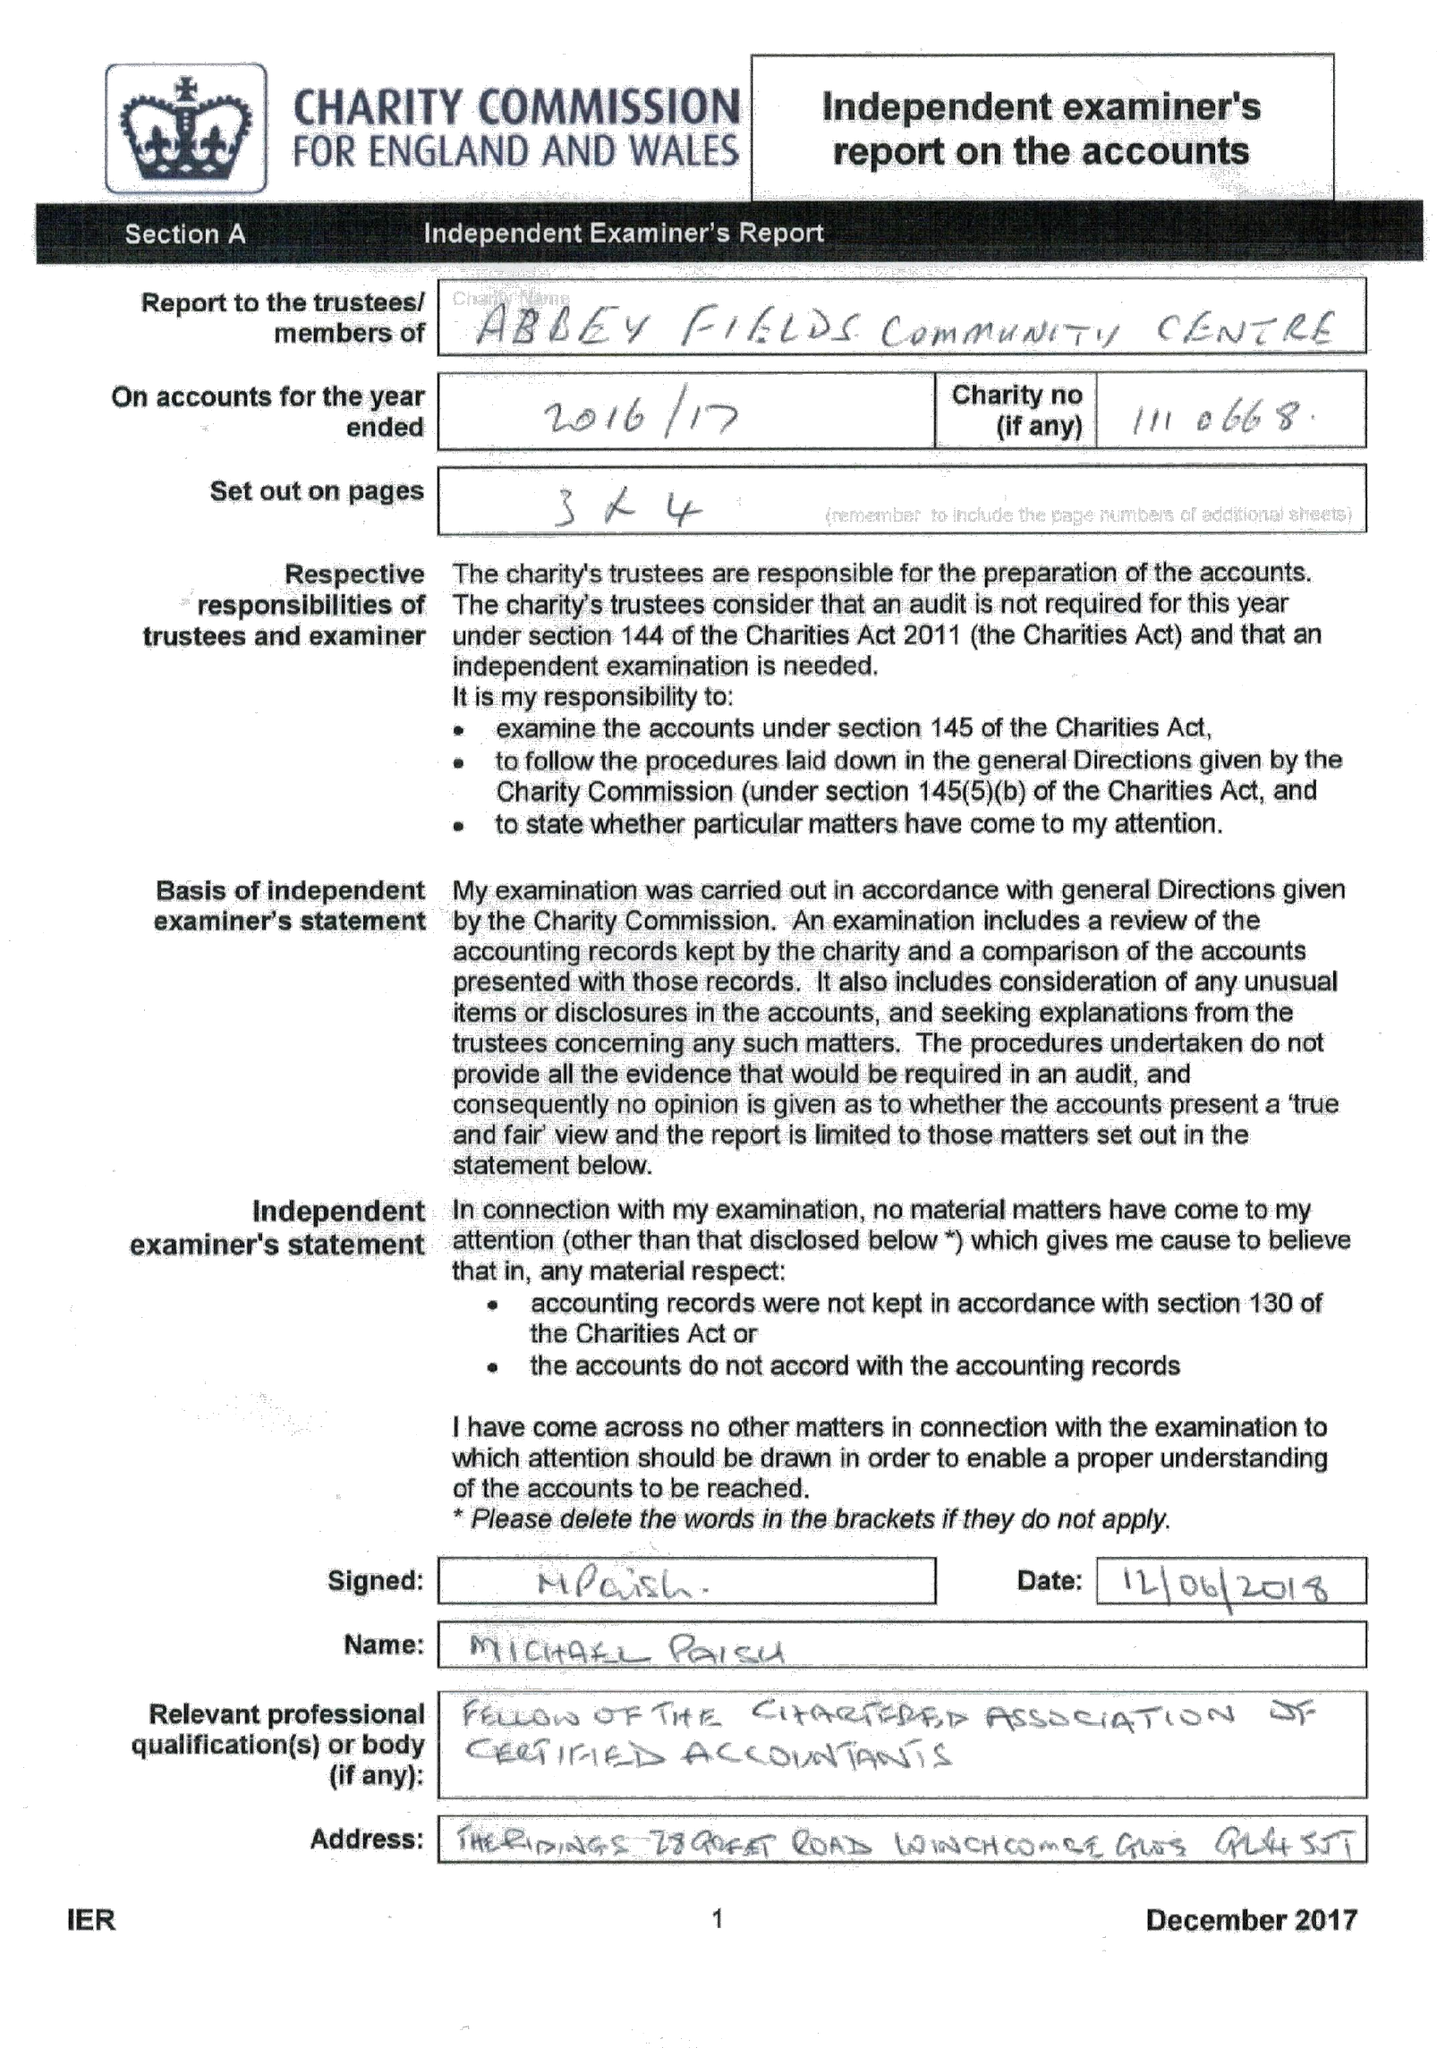What is the value for the address__postcode?
Answer the question using a single word or phrase. GL54 5QH 